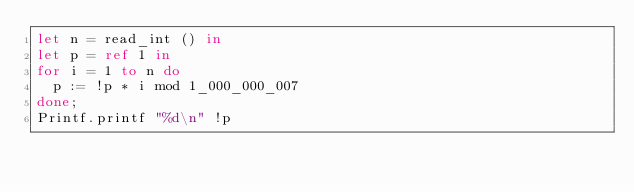<code> <loc_0><loc_0><loc_500><loc_500><_OCaml_>let n = read_int () in
let p = ref 1 in
for i = 1 to n do
  p := !p * i mod 1_000_000_007
done;
Printf.printf "%d\n" !p</code> 